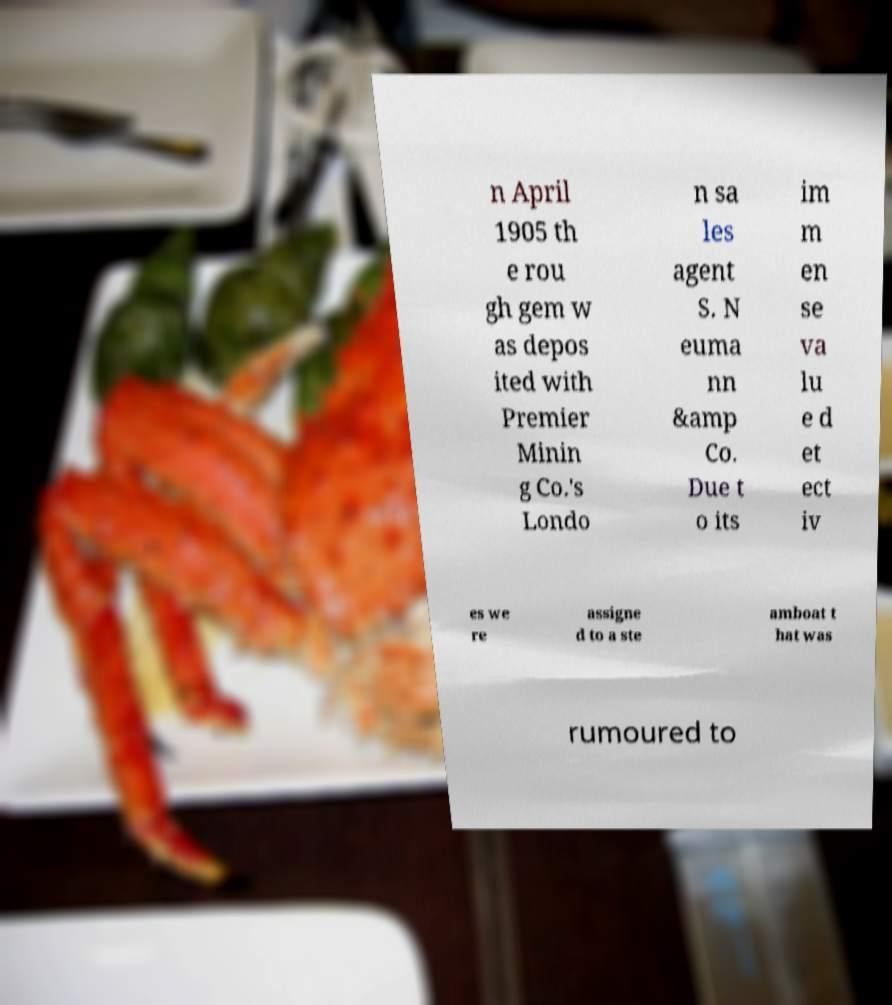Could you extract and type out the text from this image? n April 1905 th e rou gh gem w as depos ited with Premier Minin g Co.'s Londo n sa les agent S. N euma nn &amp Co. Due t o its im m en se va lu e d et ect iv es we re assigne d to a ste amboat t hat was rumoured to 